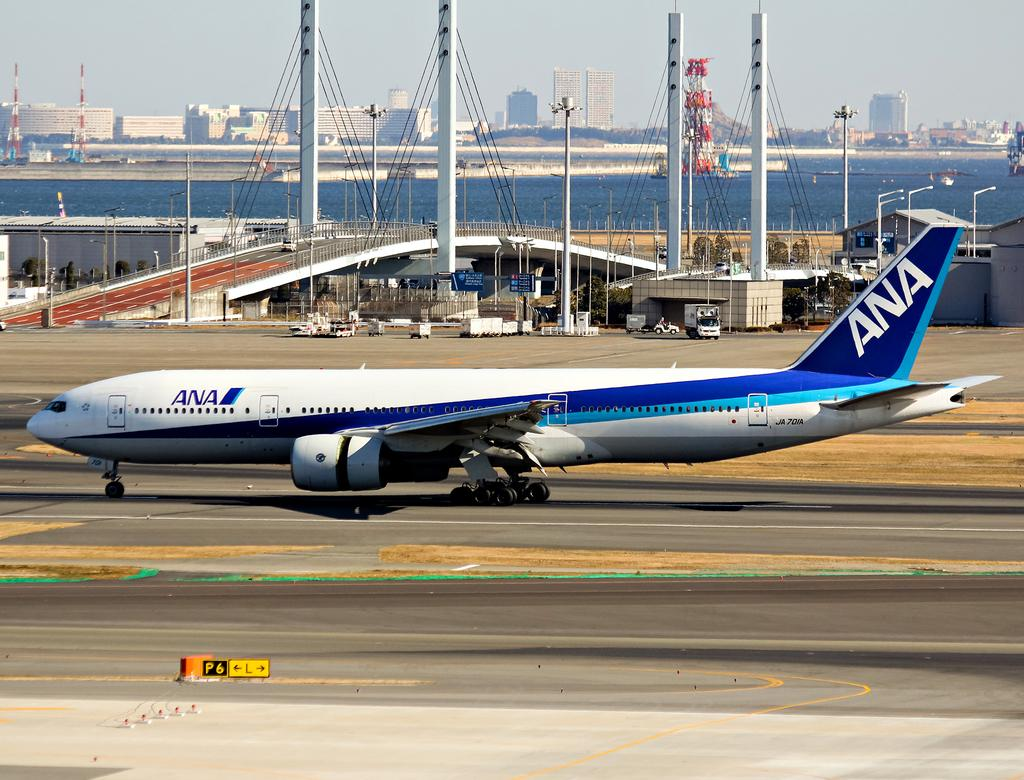<image>
Present a compact description of the photo's key features. An ANA airplane that is sitting on a runway. 